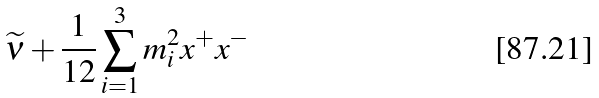<formula> <loc_0><loc_0><loc_500><loc_500>\widetilde { \nu } + \frac { 1 } { 1 2 } \sum _ { i = 1 } ^ { 3 } m _ { i } ^ { 2 } x ^ { + } x ^ { - }</formula> 